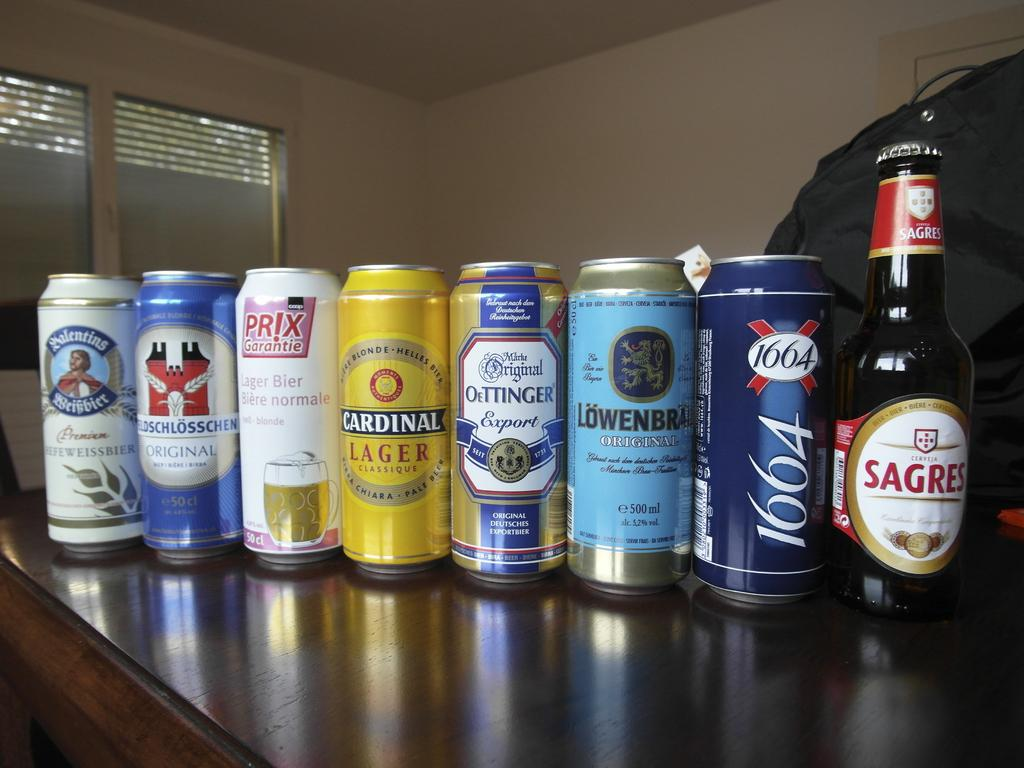<image>
Describe the image concisely. A can of Cardinal lager and several other cans of beer 